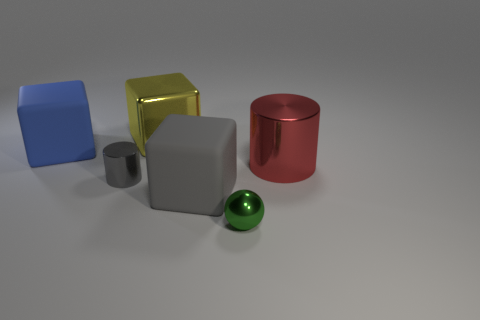There is a matte cube in front of the matte cube that is to the left of the large gray matte thing; what number of gray cylinders are to the right of it?
Give a very brief answer. 0. What number of large objects are to the left of the yellow metal block and behind the large blue thing?
Make the answer very short. 0. Is there any other thing that is the same color as the small ball?
Offer a very short reply. No. What number of metal objects are purple cylinders or tiny balls?
Ensure brevity in your answer.  1. What is the gray thing that is on the left side of the large shiny thing left of the tiny shiny object on the right side of the large yellow object made of?
Ensure brevity in your answer.  Metal. What is the material of the block in front of the cube that is left of the small cylinder?
Offer a terse response. Rubber. Do the cylinder to the right of the gray block and the blue thing left of the tiny green sphere have the same size?
Make the answer very short. Yes. How many big objects are either red rubber objects or red things?
Provide a succinct answer. 1. How many objects are either metal things right of the gray rubber object or blue rubber objects?
Provide a succinct answer. 3. What number of other objects are there of the same shape as the big yellow thing?
Make the answer very short. 2. 